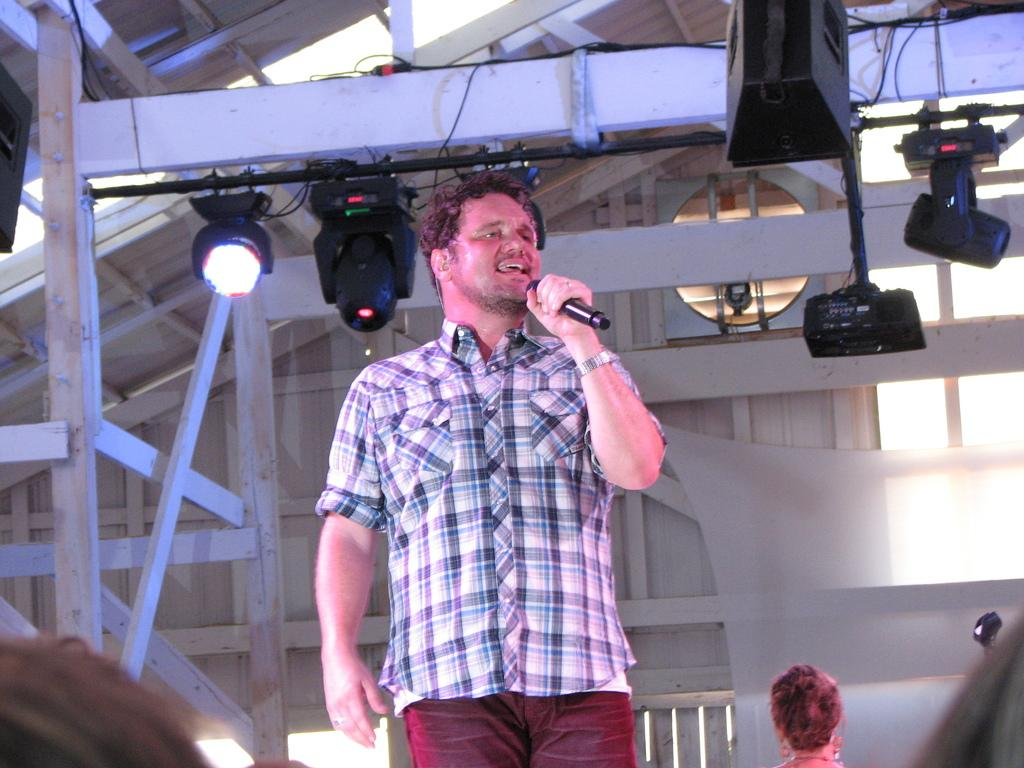Who is the main subject in the image? There is a man in the image. What is the man holding in his hands? The man is holding a microphone in his hands. What type of cloth is being used to roll up the shop in the image? There is no cloth, rolling, or shop present in the image; it only features a man holding a microphone. 